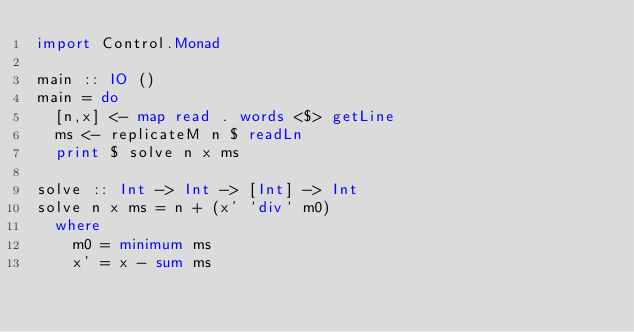<code> <loc_0><loc_0><loc_500><loc_500><_Haskell_>import Control.Monad

main :: IO ()
main = do
  [n,x] <- map read . words <$> getLine
  ms <- replicateM n $ readLn
  print $ solve n x ms 

solve :: Int -> Int -> [Int] -> Int
solve n x ms = n + (x' `div` m0)
  where
    m0 = minimum ms
    x' = x - sum ms
</code> 